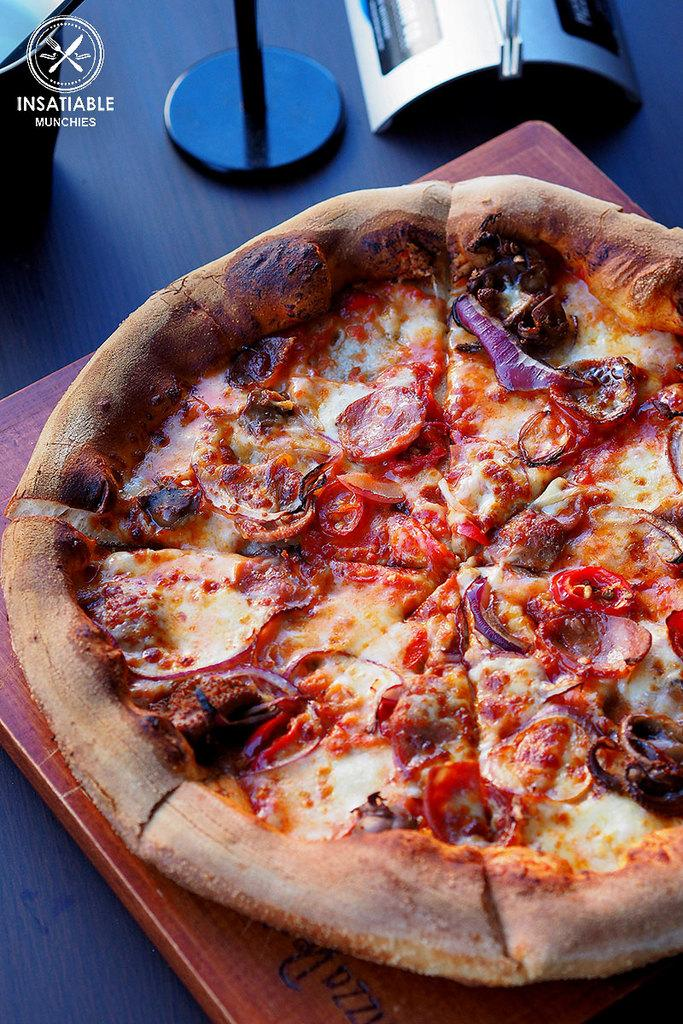What is the main subject of the image? There is a picture in the image. What is depicted in the picture? The picture contains a pizza. How is the pizza presented in the image? The pizza is on a plate. Where is the plate located in the image? The plate is on a table. What type of stick is being used to eat the pizza in the image? There is no stick present in the image; the pizza is on a plate, and the image does not show anyone eating it. 